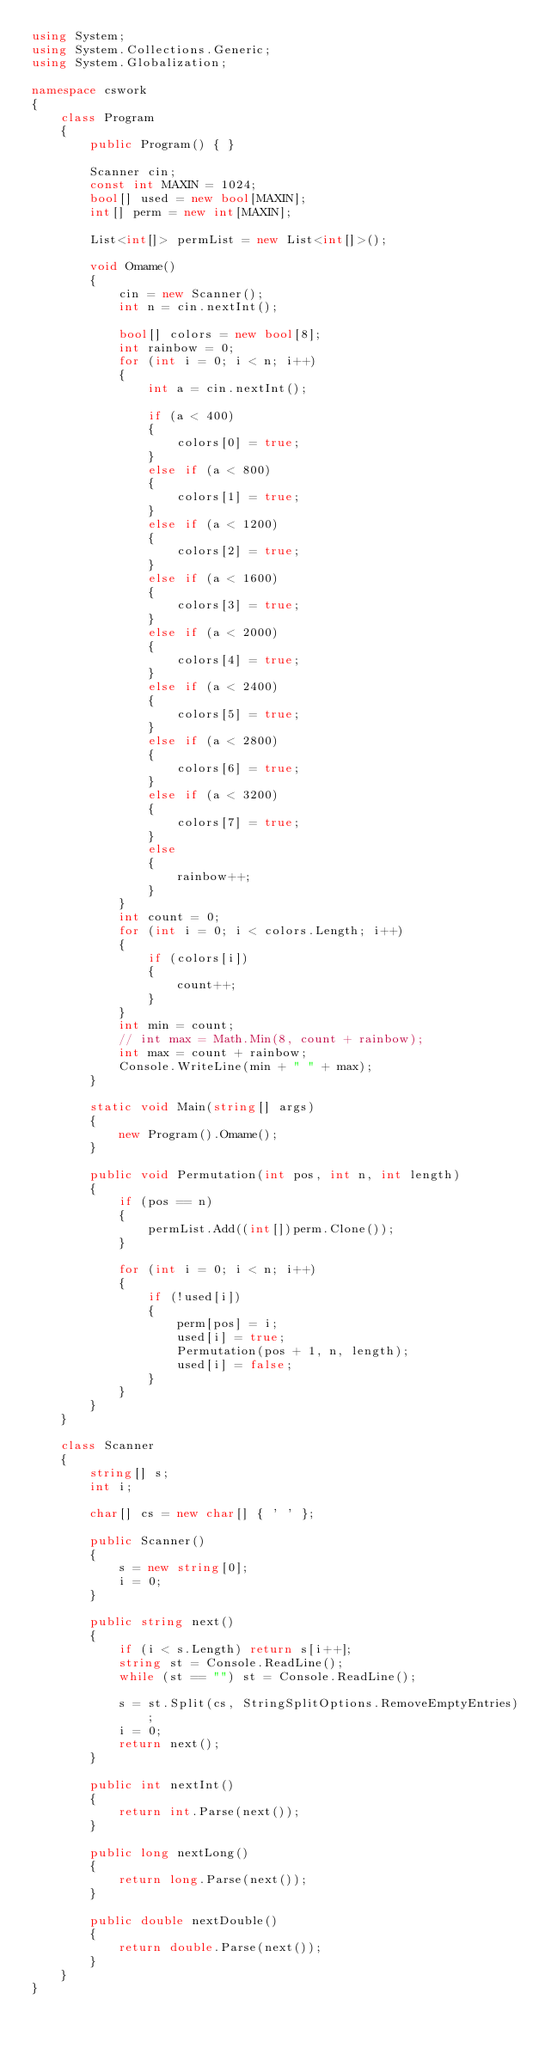Convert code to text. <code><loc_0><loc_0><loc_500><loc_500><_C#_>using System;
using System.Collections.Generic;
using System.Globalization;

namespace cswork
{
    class Program
    {
        public Program() { }

        Scanner cin;
        const int MAXIN = 1024;
        bool[] used = new bool[MAXIN];
        int[] perm = new int[MAXIN];

        List<int[]> permList = new List<int[]>();

        void Omame()
        {
            cin = new Scanner();
            int n = cin.nextInt();

            bool[] colors = new bool[8];
            int rainbow = 0;
            for (int i = 0; i < n; i++)
            {
                int a = cin.nextInt();

                if (a < 400)
                {
                    colors[0] = true;
                }
                else if (a < 800)
                {
                    colors[1] = true;
                }
                else if (a < 1200)
                {
                    colors[2] = true;
                }
                else if (a < 1600)
                {
                    colors[3] = true;
                }
                else if (a < 2000)
                {
                    colors[4] = true;
                }
                else if (a < 2400)
                {
                    colors[5] = true;
                }
                else if (a < 2800)
                {
                    colors[6] = true;
                }
                else if (a < 3200)
                {
                    colors[7] = true;
                }
                else
                {
                    rainbow++;
                }
            }
            int count = 0;
            for (int i = 0; i < colors.Length; i++)
            {
                if (colors[i])
                {
                    count++;
                }
            }
            int min = count;
            // int max = Math.Min(8, count + rainbow);
            int max = count + rainbow;
            Console.WriteLine(min + " " + max);
        }

        static void Main(string[] args)
        {
            new Program().Omame();
        }

        public void Permutation(int pos, int n, int length)
        {
            if (pos == n)
            {
                permList.Add((int[])perm.Clone());
            }

            for (int i = 0; i < n; i++)
            {
                if (!used[i])
                {
                    perm[pos] = i;
                    used[i] = true;
                    Permutation(pos + 1, n, length);
                    used[i] = false;
                }
            }
        }
    }

    class Scanner
    {
        string[] s;
        int i;

        char[] cs = new char[] { ' ' };

        public Scanner()
        {
            s = new string[0];
            i = 0;
        }

        public string next()
        {
            if (i < s.Length) return s[i++];
            string st = Console.ReadLine();
            while (st == "") st = Console.ReadLine();

            s = st.Split(cs, StringSplitOptions.RemoveEmptyEntries);
            i = 0;
            return next();
        }

        public int nextInt()
        {
            return int.Parse(next());
        }

        public long nextLong()
        {
            return long.Parse(next());
        }

        public double nextDouble()
        {
            return double.Parse(next());
        }
    }
}</code> 